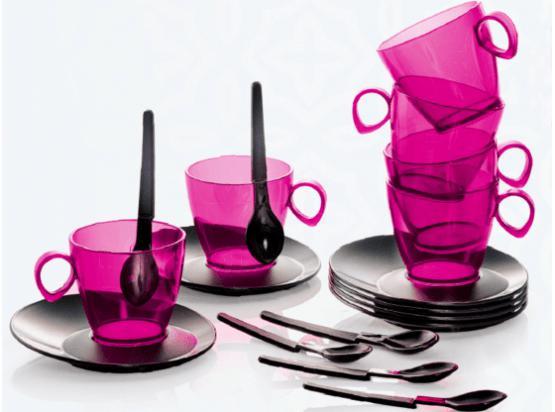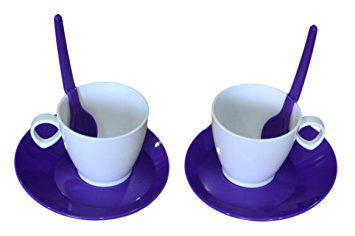The first image is the image on the left, the second image is the image on the right. Analyze the images presented: Is the assertion "Pink transparent cups are on the left image." valid? Answer yes or no. Yes. 